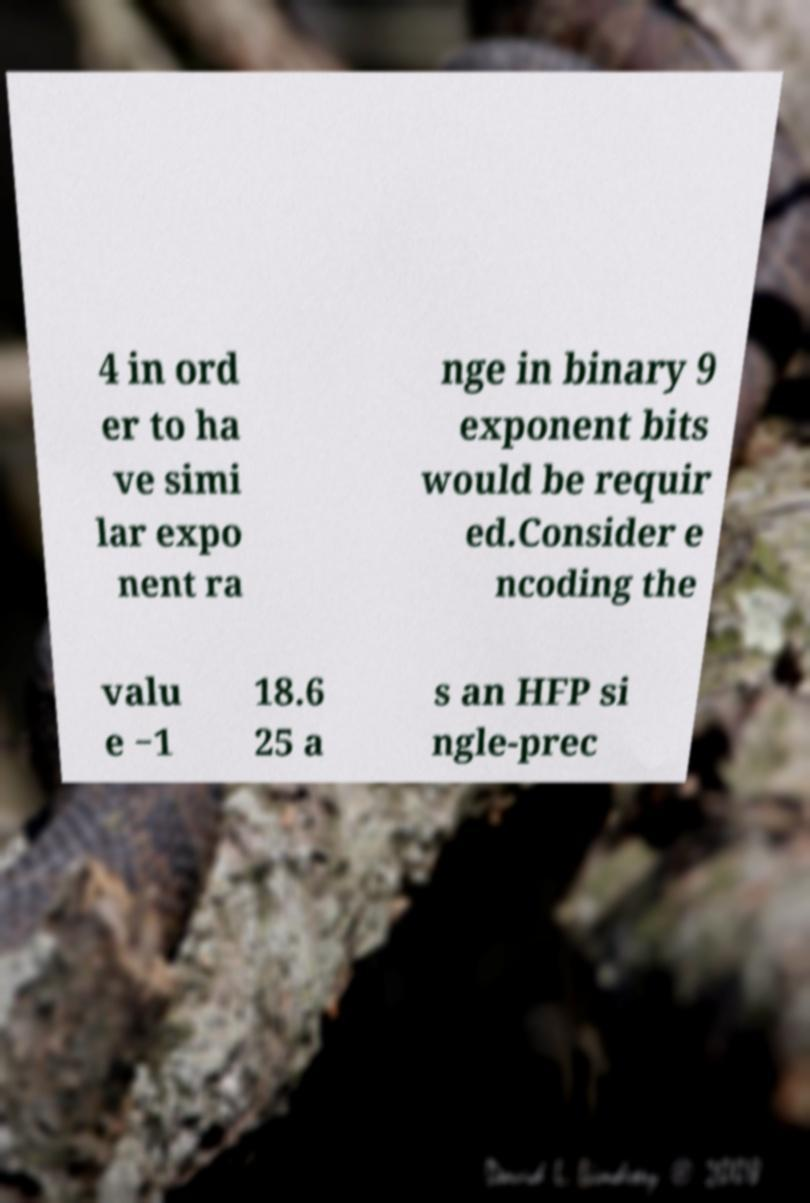What messages or text are displayed in this image? I need them in a readable, typed format. 4 in ord er to ha ve simi lar expo nent ra nge in binary 9 exponent bits would be requir ed.Consider e ncoding the valu e −1 18.6 25 a s an HFP si ngle-prec 